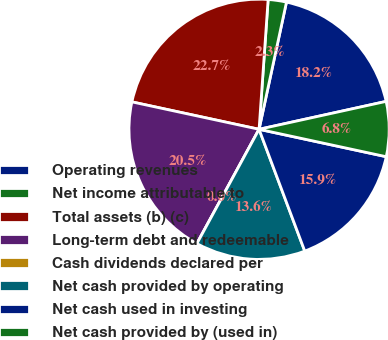Convert chart to OTSL. <chart><loc_0><loc_0><loc_500><loc_500><pie_chart><fcel>Operating revenues<fcel>Net income attributable to<fcel>Total assets (b) (c)<fcel>Long-term debt and redeemable<fcel>Cash dividends declared per<fcel>Net cash provided by operating<fcel>Net cash used in investing<fcel>Net cash provided by (used in)<nl><fcel>18.18%<fcel>2.27%<fcel>22.73%<fcel>20.45%<fcel>0.0%<fcel>13.64%<fcel>15.91%<fcel>6.82%<nl></chart> 